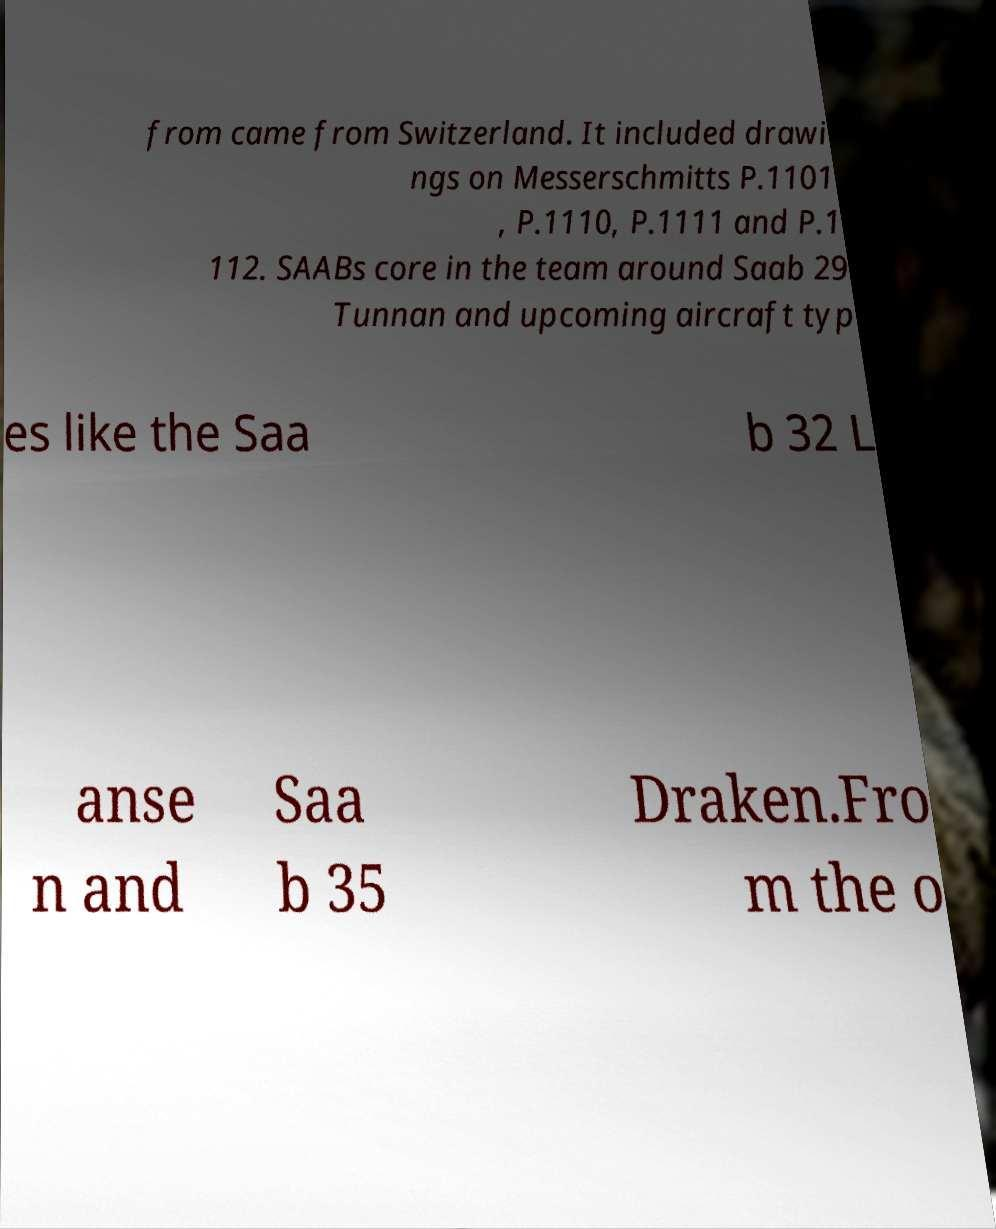Please identify and transcribe the text found in this image. from came from Switzerland. It included drawi ngs on Messerschmitts P.1101 , P.1110, P.1111 and P.1 112. SAABs core in the team around Saab 29 Tunnan and upcoming aircraft typ es like the Saa b 32 L anse n and Saa b 35 Draken.Fro m the o 